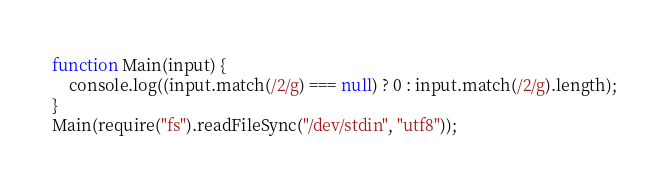Convert code to text. <code><loc_0><loc_0><loc_500><loc_500><_JavaScript_>function Main(input) {
	console.log((input.match(/2/g) === null) ? 0 : input.match(/2/g).length);
}
Main(require("fs").readFileSync("/dev/stdin", "utf8"));</code> 